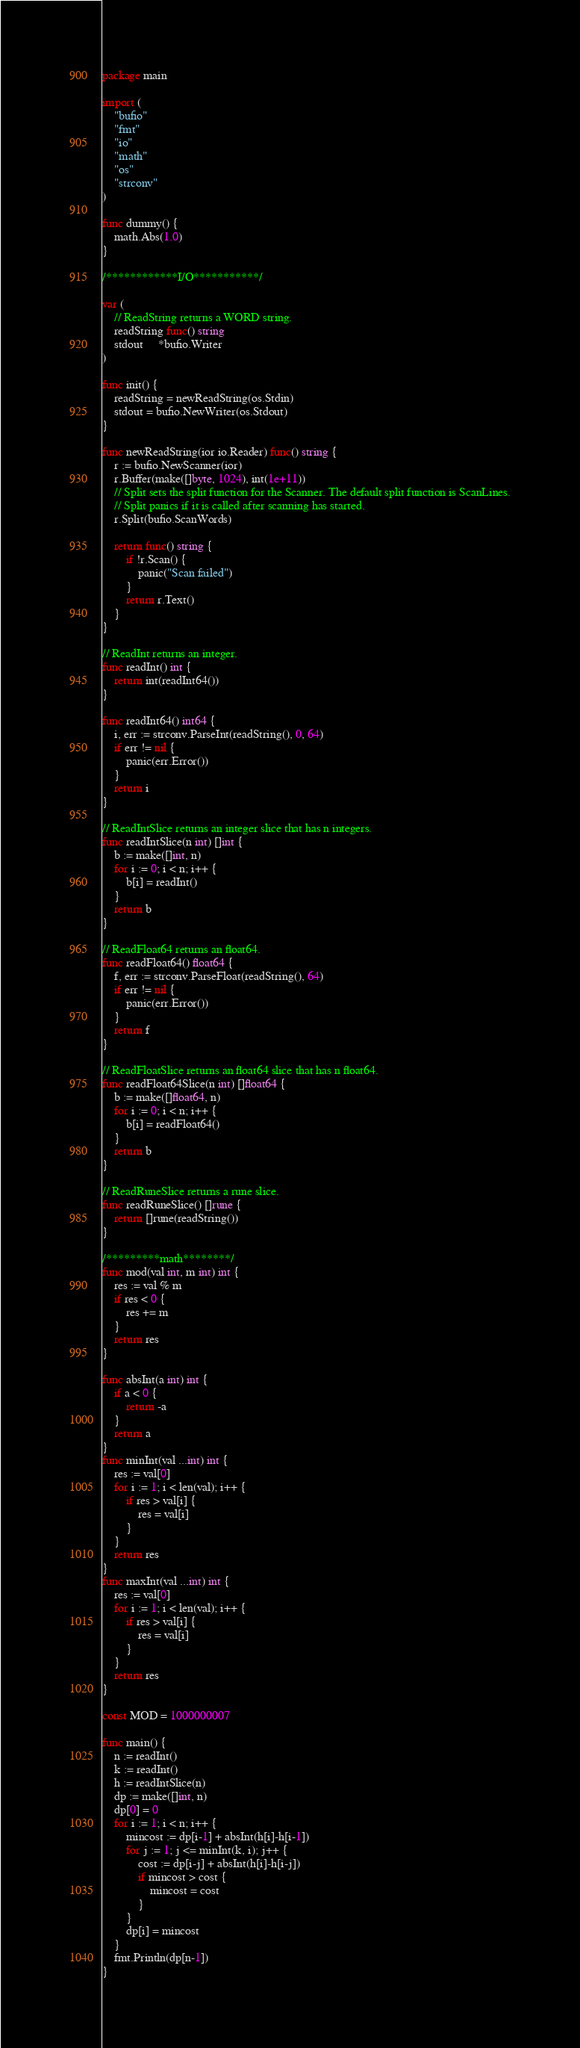Convert code to text. <code><loc_0><loc_0><loc_500><loc_500><_Go_>package main

import (
	"bufio"
	"fmt"
	"io"
	"math"
	"os"
	"strconv"
)

func dummy() {
	math.Abs(1.0)
}

/************I/O***********/

var (
	// ReadString returns a WORD string.
	readString func() string
	stdout     *bufio.Writer
)

func init() {
	readString = newReadString(os.Stdin)
	stdout = bufio.NewWriter(os.Stdout)
}

func newReadString(ior io.Reader) func() string {
	r := bufio.NewScanner(ior)
	r.Buffer(make([]byte, 1024), int(1e+11))
	// Split sets the split function for the Scanner. The default split function is ScanLines.
	// Split panics if it is called after scanning has started.
	r.Split(bufio.ScanWords)

	return func() string {
		if !r.Scan() {
			panic("Scan failed")
		}
		return r.Text()
	}
}

// ReadInt returns an integer.
func readInt() int {
	return int(readInt64())
}

func readInt64() int64 {
	i, err := strconv.ParseInt(readString(), 0, 64)
	if err != nil {
		panic(err.Error())
	}
	return i
}

// ReadIntSlice returns an integer slice that has n integers.
func readIntSlice(n int) []int {
	b := make([]int, n)
	for i := 0; i < n; i++ {
		b[i] = readInt()
	}
	return b
}

// ReadFloat64 returns an float64.
func readFloat64() float64 {
	f, err := strconv.ParseFloat(readString(), 64)
	if err != nil {
		panic(err.Error())
	}
	return f
}

// ReadFloatSlice returns an float64 slice that has n float64.
func readFloat64Slice(n int) []float64 {
	b := make([]float64, n)
	for i := 0; i < n; i++ {
		b[i] = readFloat64()
	}
	return b
}

// ReadRuneSlice returns a rune slice.
func readRuneSlice() []rune {
	return []rune(readString())
}

/*********math********/
func mod(val int, m int) int {
	res := val % m
	if res < 0 {
		res += m
	}
	return res
}

func absInt(a int) int {
	if a < 0 {
		return -a
	}
	return a
}
func minInt(val ...int) int {
	res := val[0]
	for i := 1; i < len(val); i++ {
		if res > val[i] {
			res = val[i]
		}
	}
	return res
}
func maxInt(val ...int) int {
	res := val[0]
	for i := 1; i < len(val); i++ {
		if res > val[i] {
			res = val[i]
		}
	}
	return res
}

const MOD = 1000000007

func main() {
	n := readInt()
	k := readInt()
	h := readIntSlice(n)
	dp := make([]int, n)
	dp[0] = 0
	for i := 1; i < n; i++ {
		mincost := dp[i-1] + absInt(h[i]-h[i-1])
		for j := 1; j <= minInt(k, i); j++ {
			cost := dp[i-j] + absInt(h[i]-h[i-j])
			if mincost > cost {
				mincost = cost
			}
		}
		dp[i] = mincost
	}
	fmt.Println(dp[n-1])
}
</code> 